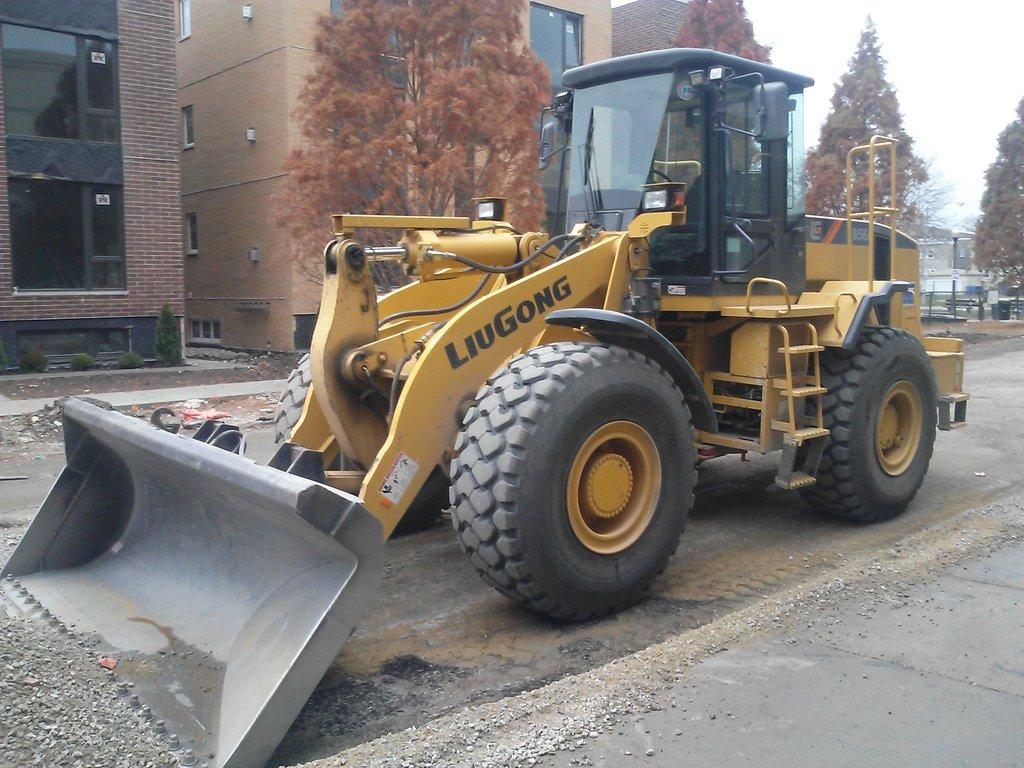What type of vehicle is in the image? There is a bulldozer in the image. What colors can be seen on the bulldozer? The bulldozer is yellow and black in color. Where is the bulldozer located in the image? The bulldozer is on the road. What can be seen in the background of the image? There are buildings, brown trees, and the sky visible in the background of the image. What type of sweater is the parent wearing in the image? There is no parent or sweater present in the image; it features a bulldozer on the road with buildings, trees, and the sky in the background. 